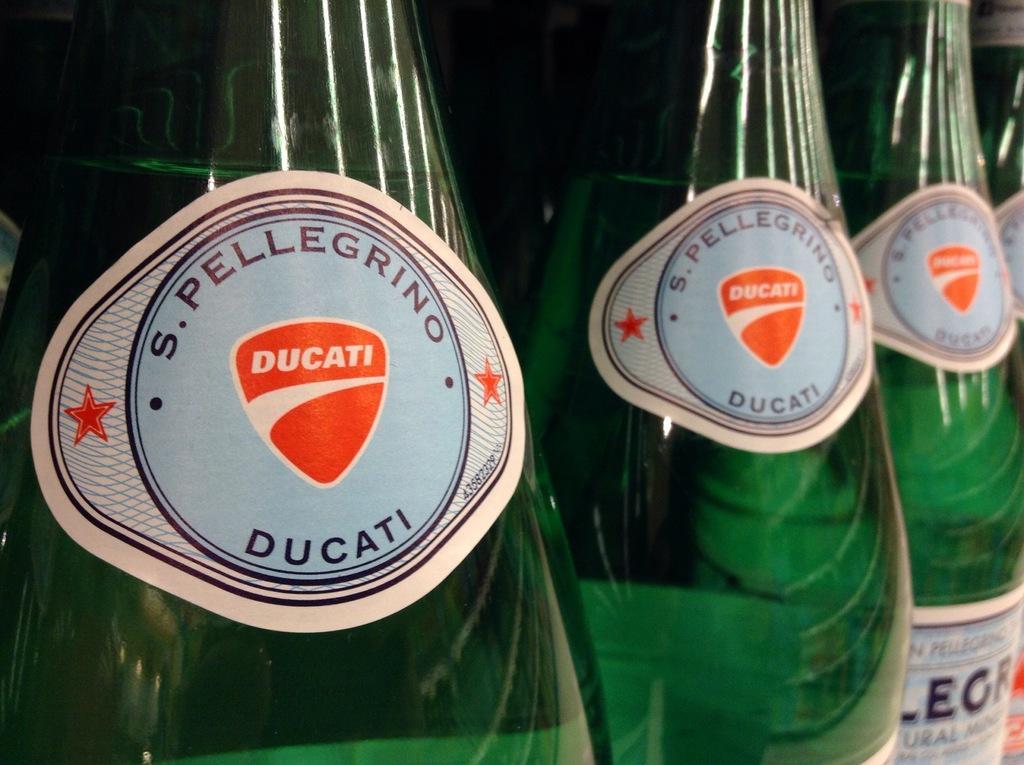How would you summarize this image in a sentence or two? In the image there are few bottles. 